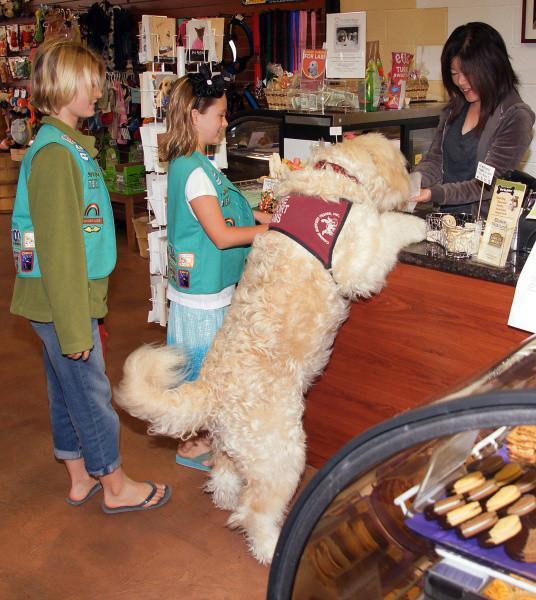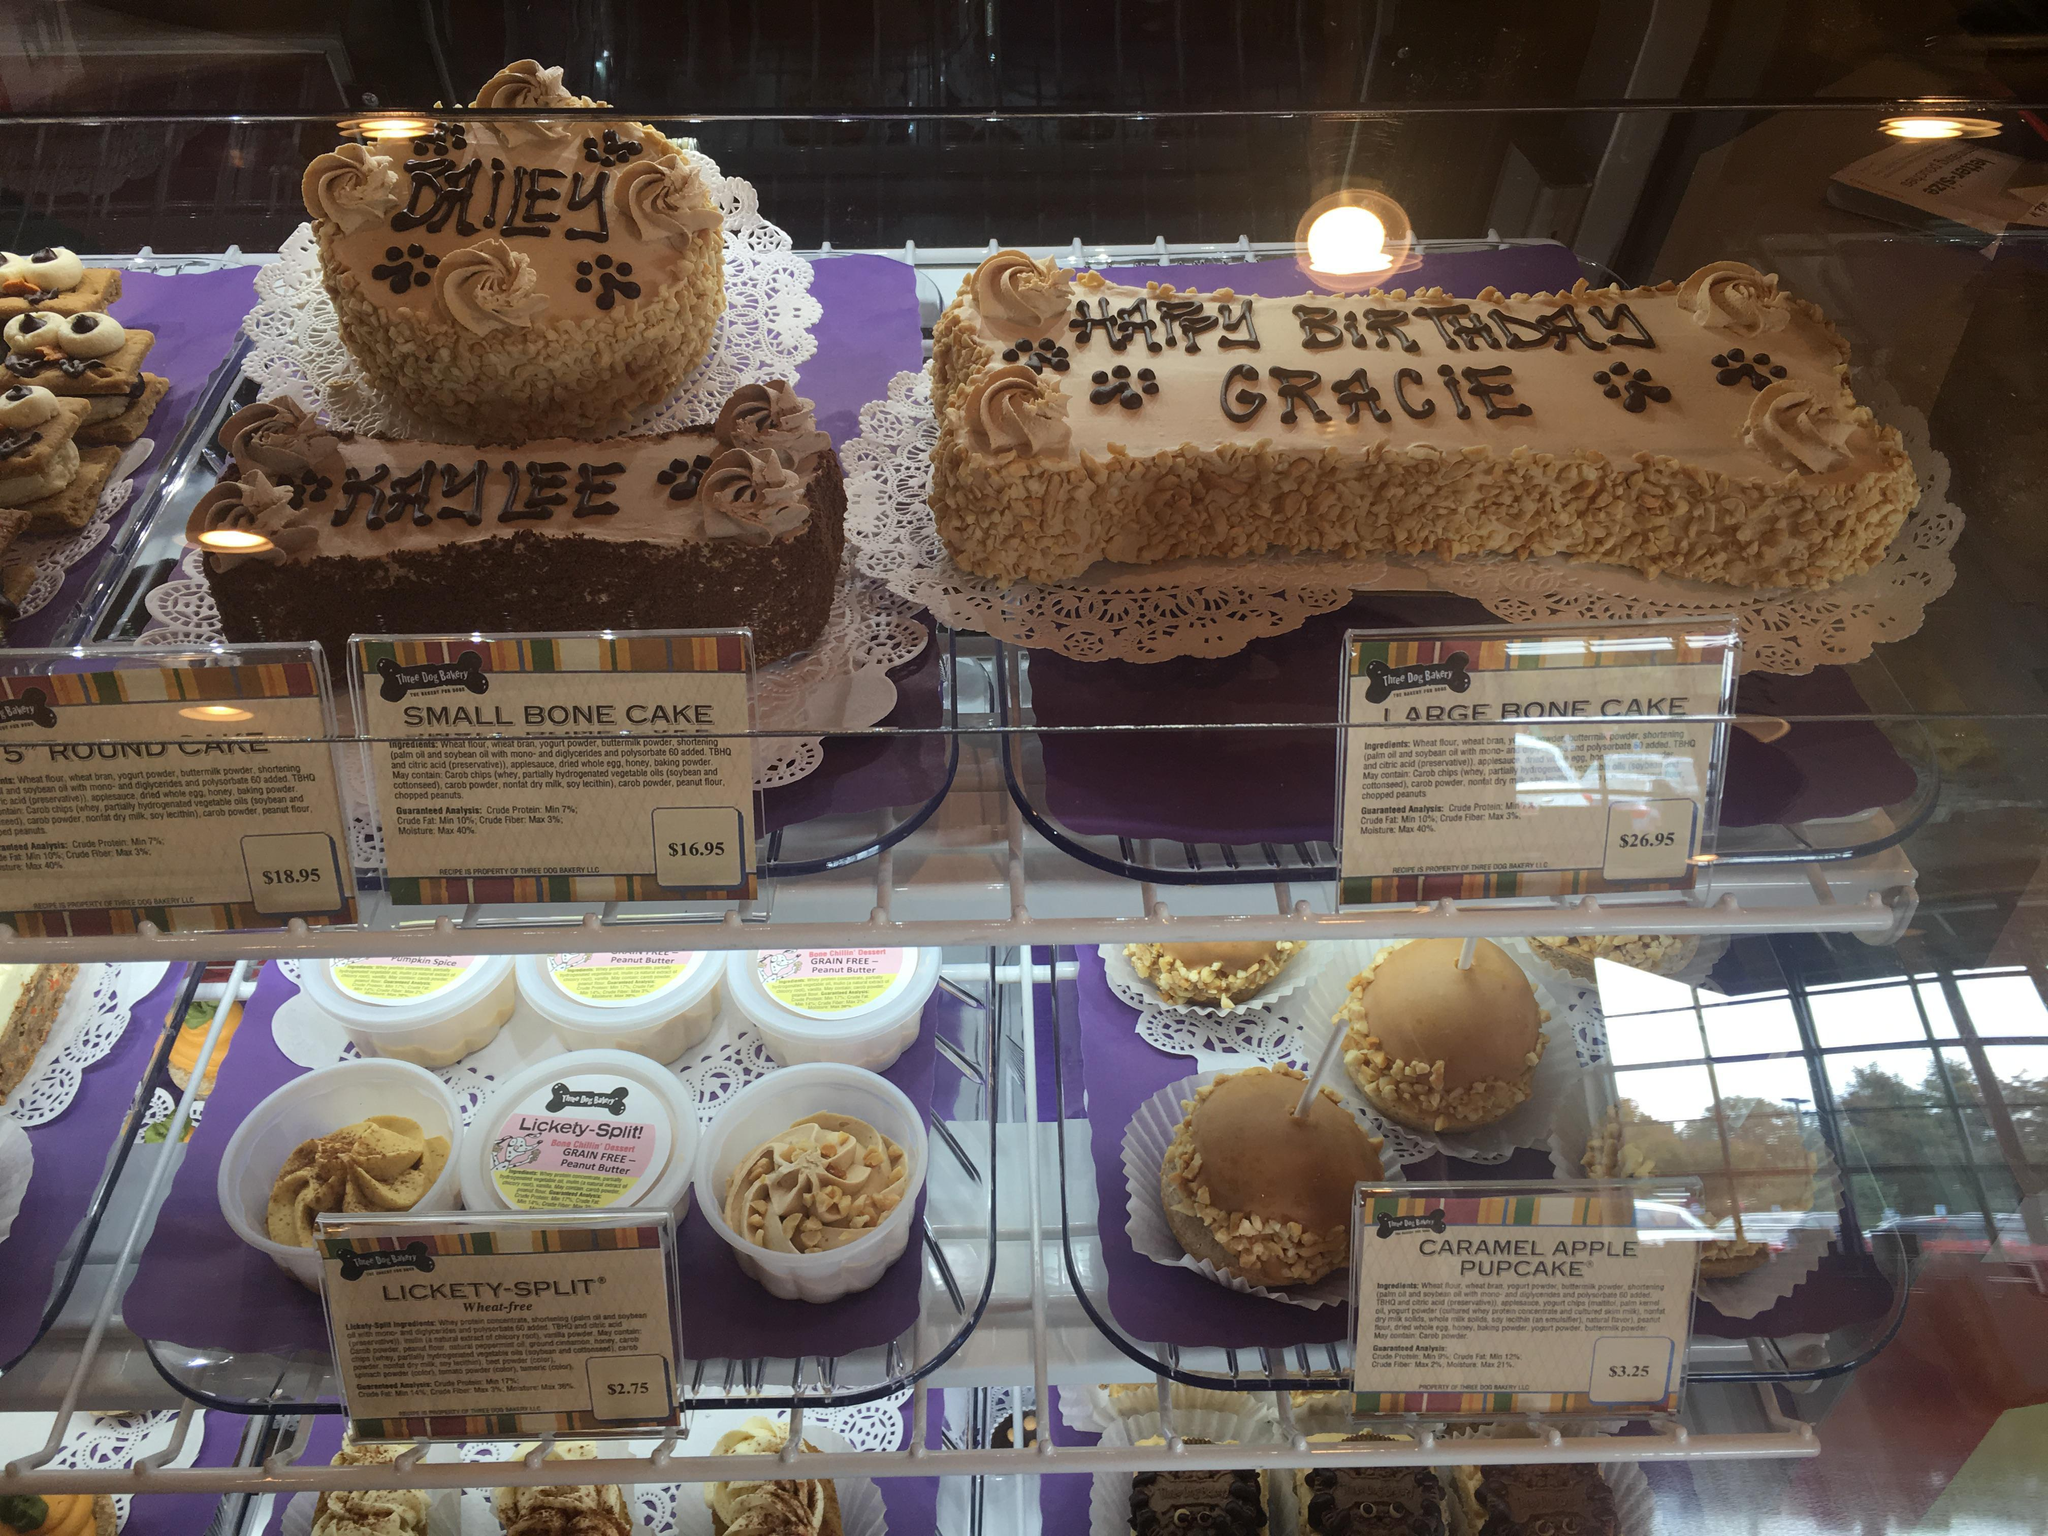The first image is the image on the left, the second image is the image on the right. Assess this claim about the two images: "An image shows a golden-haired right-facing dog standing with its front paws propped atop a wood-front counter.". Correct or not? Answer yes or no. Yes. The first image is the image on the left, the second image is the image on the right. Assess this claim about the two images: "A dog has its front paws on the counter in the image on the right.". Correct or not? Answer yes or no. No. 